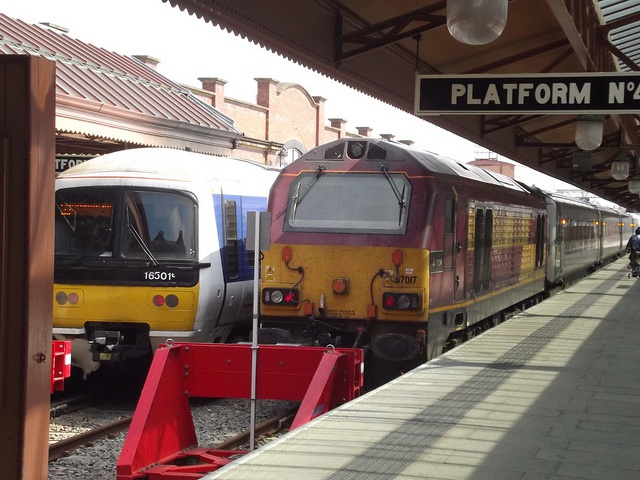Describe the objects in this image and their specific colors. I can see train in white, black, gray, and maroon tones, train in white, black, gray, and olive tones, and people in white, black, gray, and darkgray tones in this image. 